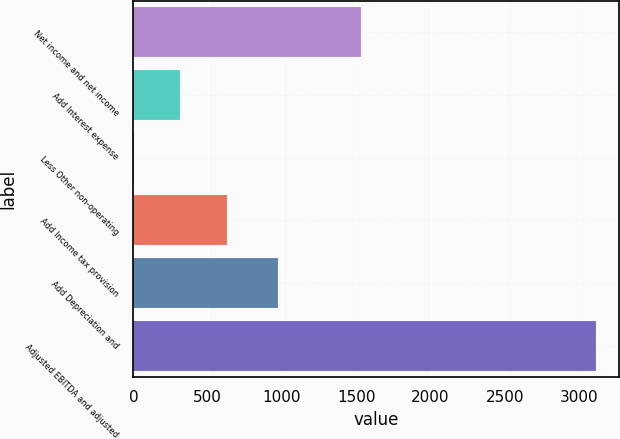<chart> <loc_0><loc_0><loc_500><loc_500><bar_chart><fcel>Net income and net income<fcel>Add Interest expense<fcel>Less Other non-operating<fcel>Add Income tax provision<fcel>Add Depreciation and<fcel>Adjusted EBITDA and adjusted<nl><fcel>1532.9<fcel>316.14<fcel>5.1<fcel>627.18<fcel>970.7<fcel>3115.5<nl></chart> 